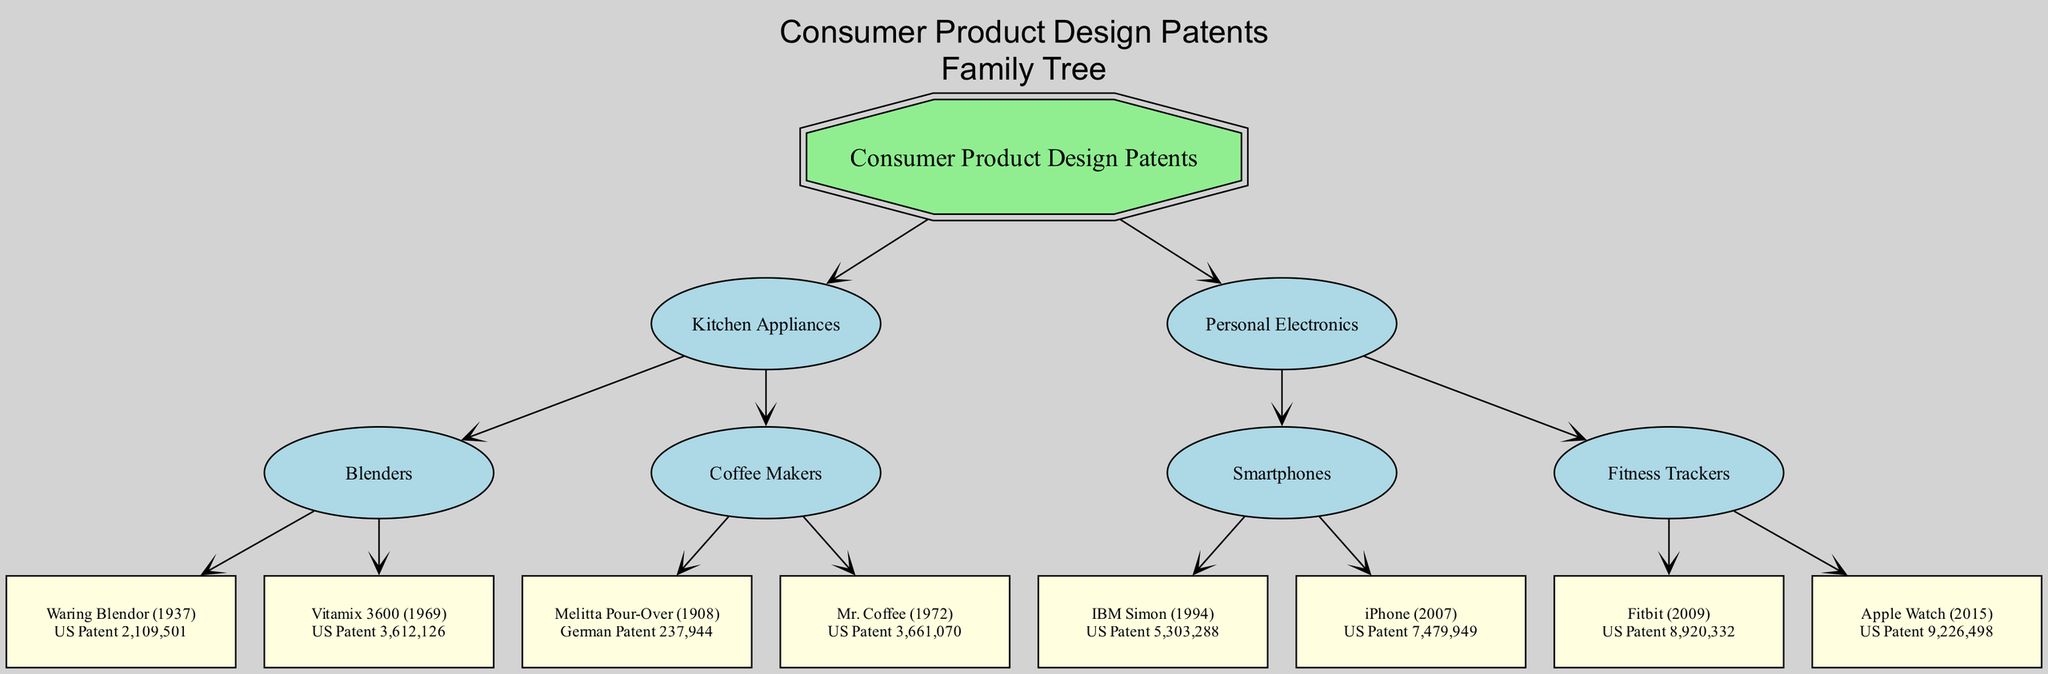What is the root node of the family tree? The root node is labeled "Consumer Product Design Patents," which signifies the overall category of the diagram. This is the starting point from which all other branches emerge.
Answer: Consumer Product Design Patents How many main branches are in the family tree? The family tree contains two main branches: "Kitchen Appliances" and "Personal Electronics." Each branch represents a significant category within the consumer product design patents.
Answer: 2 Which product was patented in 1908 under Kitchen Appliances? The product patented in 1908 is the "Melitta Pour-Over," which falls under the Coffee Makers category of Kitchen Appliances. This can be identified by traversing down the relevant branch.
Answer: Melitta Pour-Over What patent is associated with the iPhone? The patent associated with the iPhone is "US Patent 7,479,949," and this information can be found within the Personal Electronics branch under the Smartphones category.
Answer: US Patent 7,479,949 Which consumer product was introduced first, the Waring Blendor or the Vitamix 3600? The Waring Blendor was introduced in 1937, while the Vitamix 3600 was introduced in 1969, making the Waring Blendor the earlier product. This is determined by comparing the introduction years listed next to each product.
Answer: Waring Blendor How many patents are listed under the Fitness Trackers category? There are two patents listed under "Fitness Trackers": one for Fitbit (2009) and one for Apple Watch (2015). Each of these corresponds to a specific product in that category, indicating a count of two patents.
Answer: 2 What is the relationship between "Smartphones" and "Personal Electronics"? "Smartphones" is a child node of the "Personal Electronics" branch, indicating that smartphones are a specific category within the broader field of personal electronics. This relationship shows that smartphones are a subset of personal electronics products.
Answer: Child node Which Coffee Maker product was patented first? The "Melitta Pour-Over" product, patented in 1908, was introduced before "Mr. Coffee," which was patented in 1972. This is determined by comparing the years listed next to each product under the Coffee Makers category.
Answer: Melitta Pour-Over What type of diagram is this? The diagram is a "family tree," which visually represents the ancestry of consumer product design patents by organizing them into branches and nodes based on their categories and its evolutionary relationships.
Answer: Family tree 